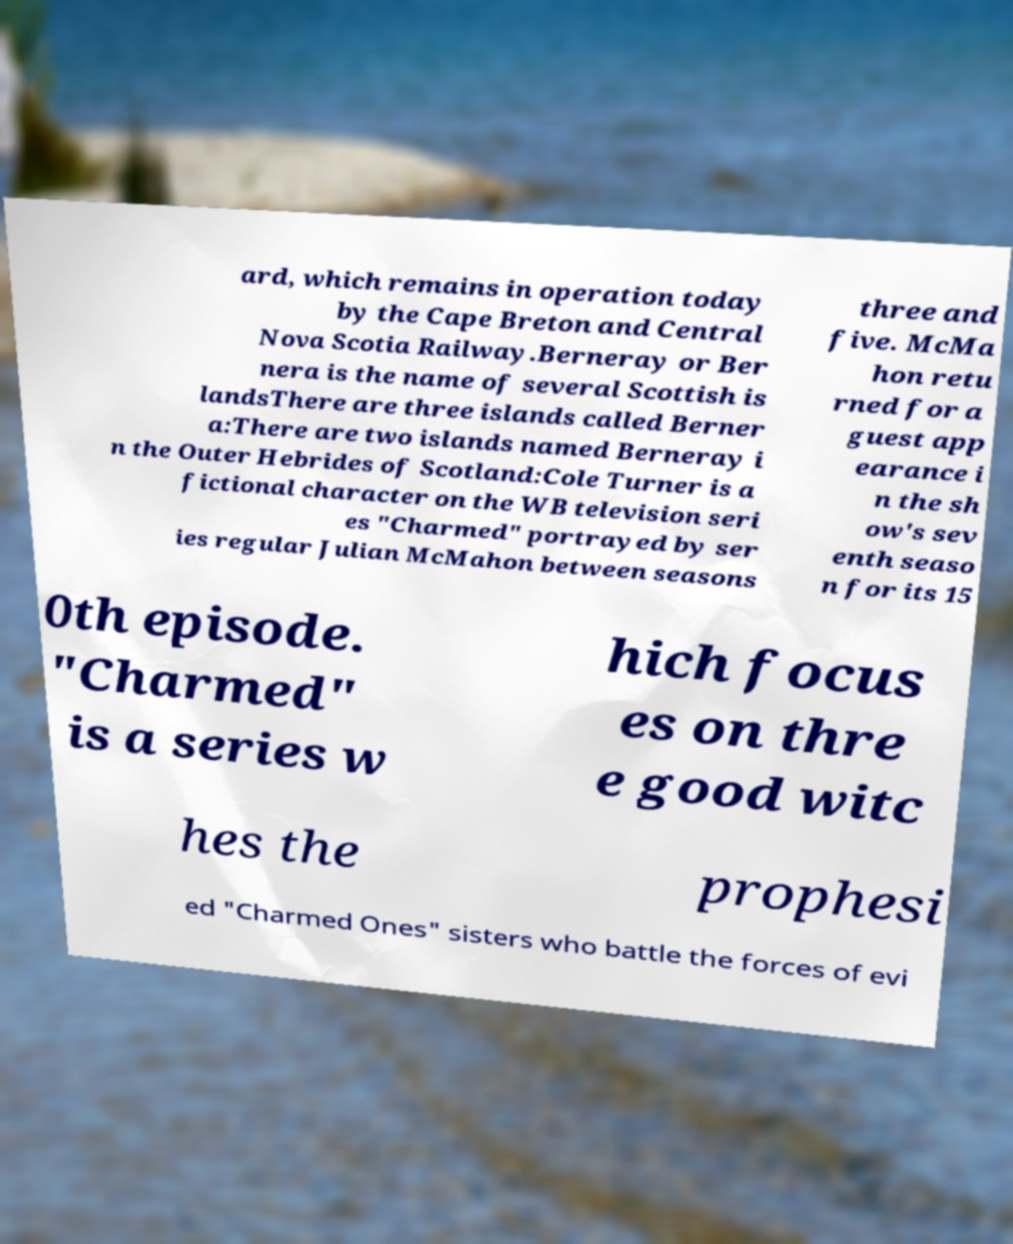For documentation purposes, I need the text within this image transcribed. Could you provide that? ard, which remains in operation today by the Cape Breton and Central Nova Scotia Railway.Berneray or Ber nera is the name of several Scottish is landsThere are three islands called Berner a:There are two islands named Berneray i n the Outer Hebrides of Scotland:Cole Turner is a fictional character on the WB television seri es "Charmed" portrayed by ser ies regular Julian McMahon between seasons three and five. McMa hon retu rned for a guest app earance i n the sh ow's sev enth seaso n for its 15 0th episode. "Charmed" is a series w hich focus es on thre e good witc hes the prophesi ed "Charmed Ones" sisters who battle the forces of evi 